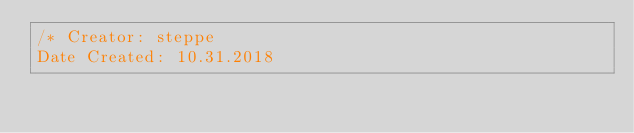Convert code to text. <code><loc_0><loc_0><loc_500><loc_500><_CSS_>/* Creator: steppe
Date Created: 10.31.2018</code> 